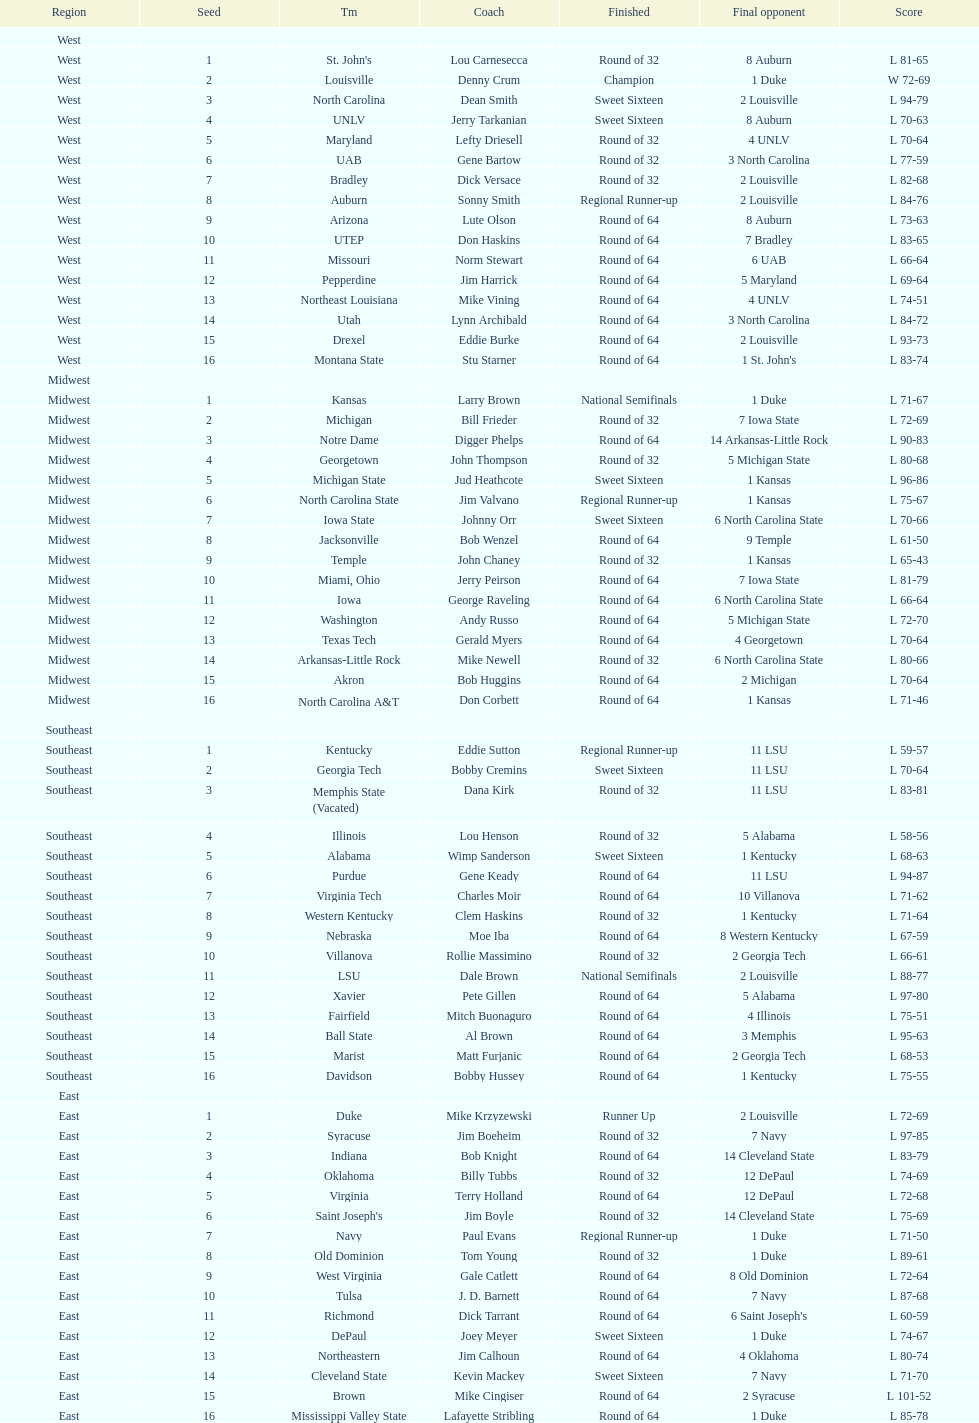How many teams are present in the east region? 16. 